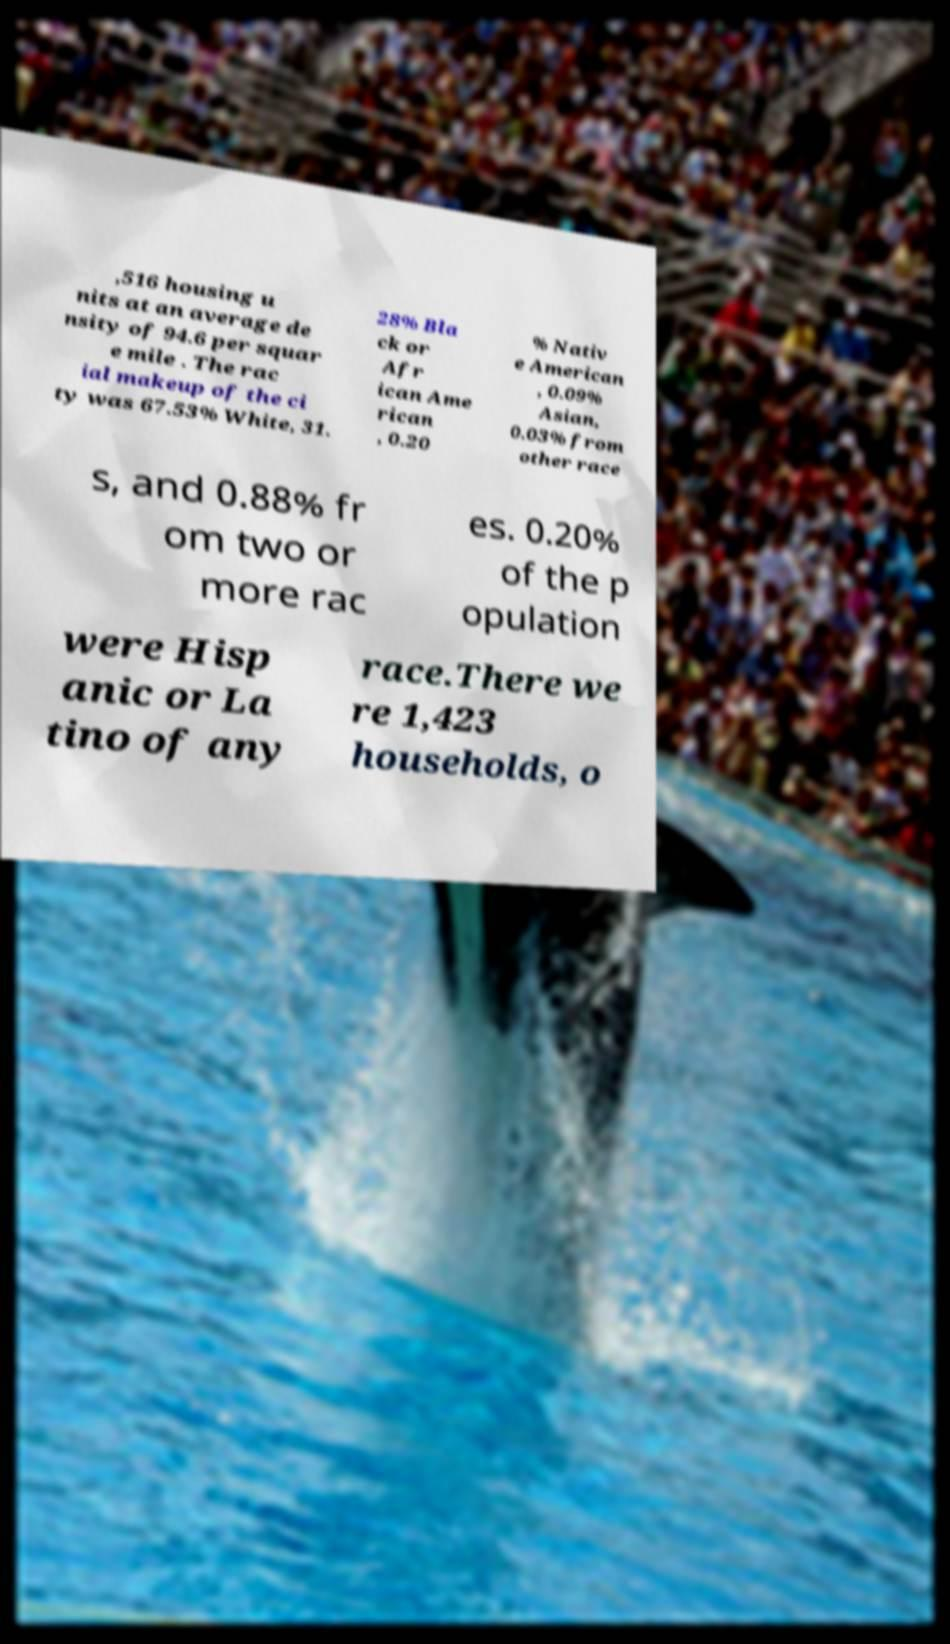Can you accurately transcribe the text from the provided image for me? ,516 housing u nits at an average de nsity of 94.6 per squar e mile . The rac ial makeup of the ci ty was 67.53% White, 31. 28% Bla ck or Afr ican Ame rican , 0.20 % Nativ e American , 0.09% Asian, 0.03% from other race s, and 0.88% fr om two or more rac es. 0.20% of the p opulation were Hisp anic or La tino of any race.There we re 1,423 households, o 